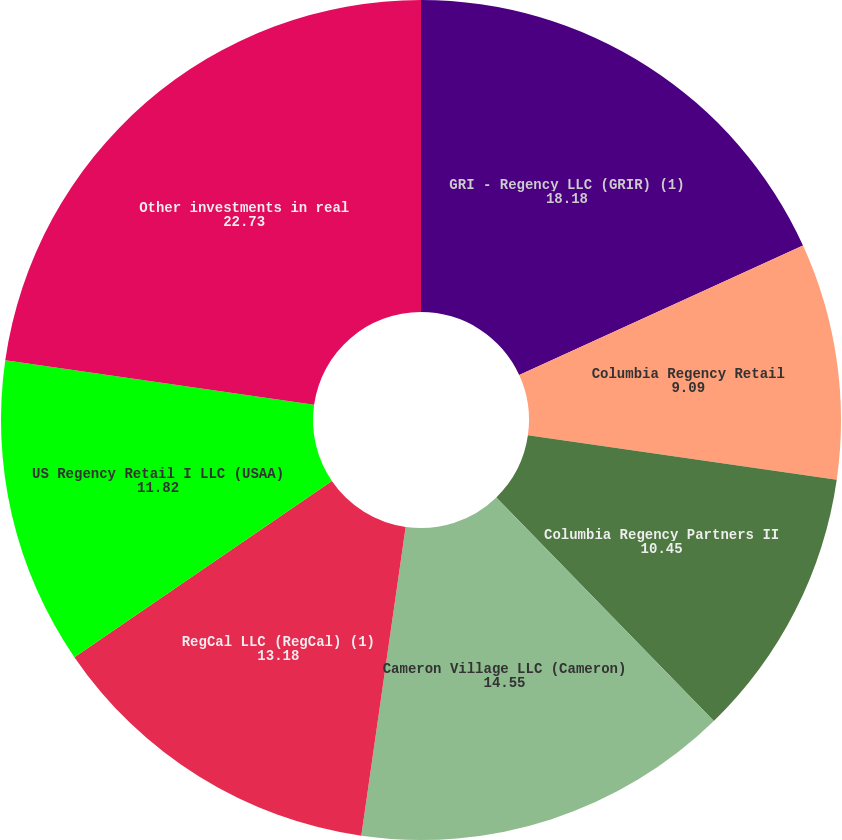<chart> <loc_0><loc_0><loc_500><loc_500><pie_chart><fcel>GRI - Regency LLC (GRIR) (1)<fcel>Columbia Regency Retail<fcel>Columbia Regency Partners II<fcel>Cameron Village LLC (Cameron)<fcel>RegCal LLC (RegCal) (1)<fcel>US Regency Retail I LLC (USAA)<fcel>Other investments in real<nl><fcel>18.18%<fcel>9.09%<fcel>10.45%<fcel>14.55%<fcel>13.18%<fcel>11.82%<fcel>22.73%<nl></chart> 